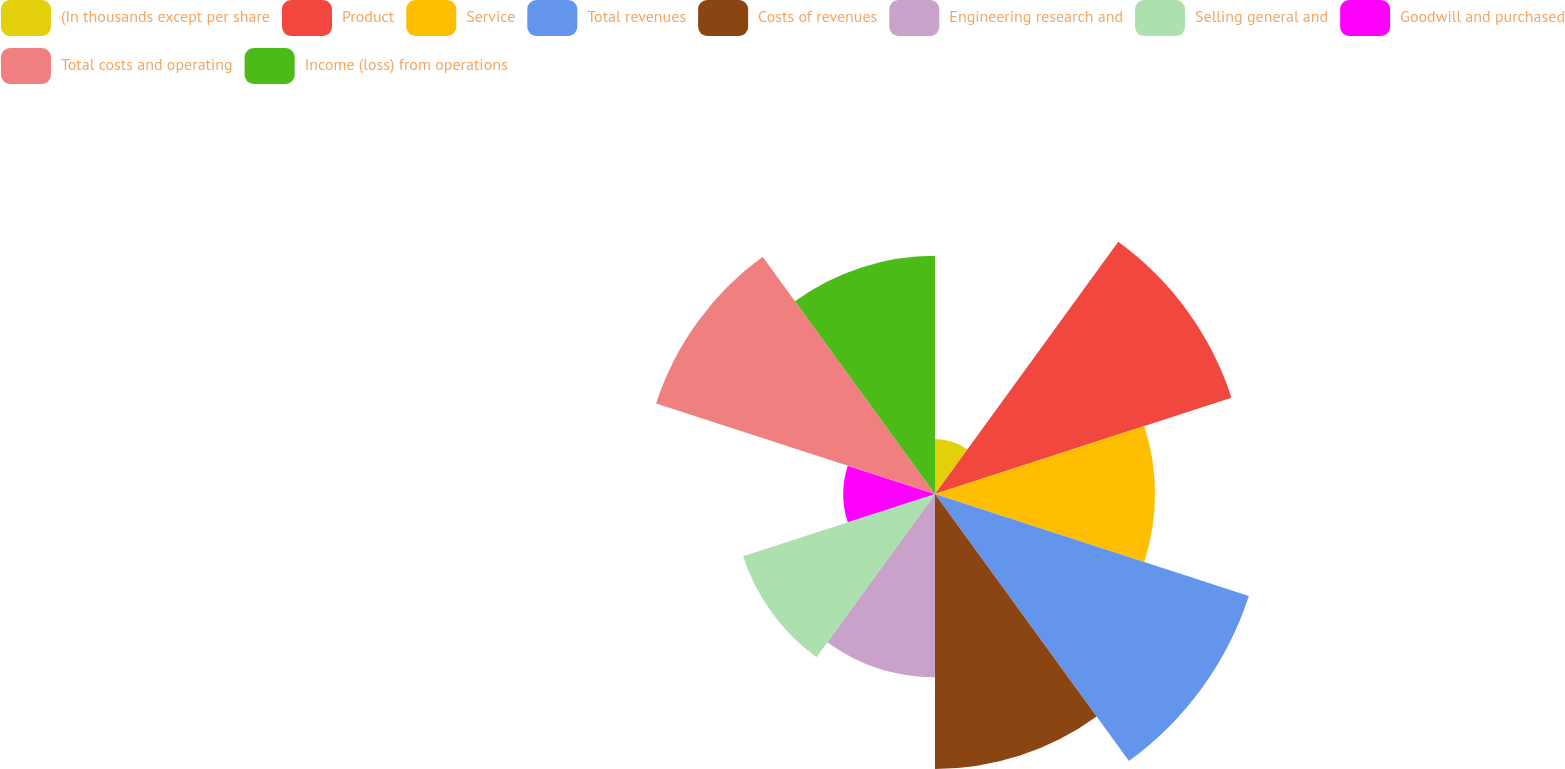<chart> <loc_0><loc_0><loc_500><loc_500><pie_chart><fcel>(In thousands except per share<fcel>Product<fcel>Service<fcel>Total revenues<fcel>Costs of revenues<fcel>Engineering research and<fcel>Selling general and<fcel>Goodwill and purchased<fcel>Total costs and operating<fcel>Income (loss) from operations<nl><fcel>2.5%<fcel>14.17%<fcel>10.0%<fcel>15.0%<fcel>12.5%<fcel>8.33%<fcel>9.17%<fcel>4.17%<fcel>13.33%<fcel>10.83%<nl></chart> 